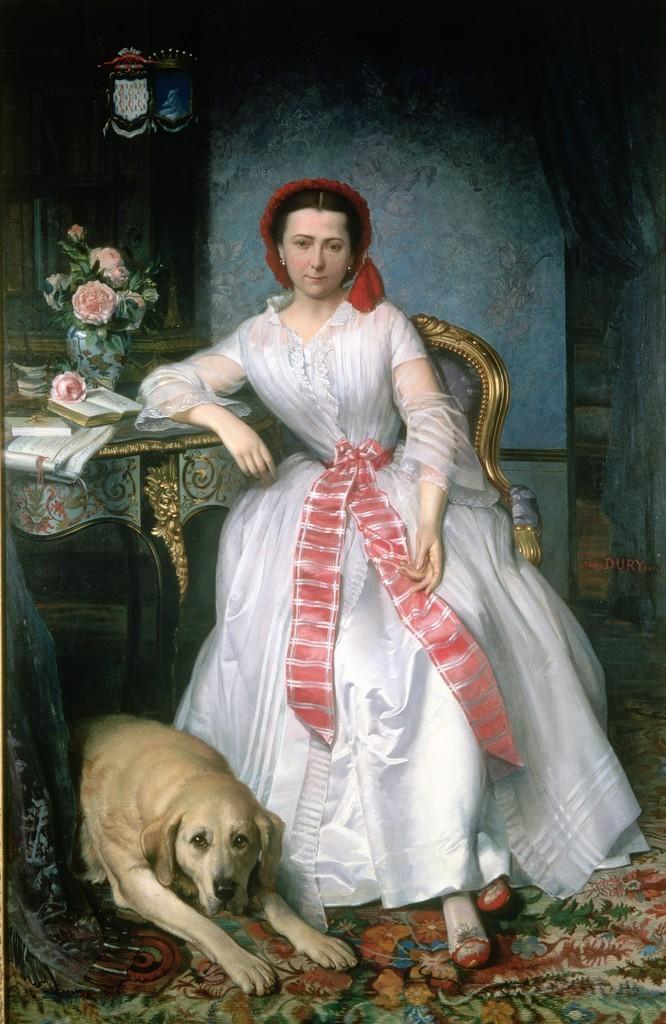Can you describe this image briefly? It is a painting, in this a beautiful woman is sitting on the chair, she wore white color dress. On the left side there is a dog sitting on the floor. 